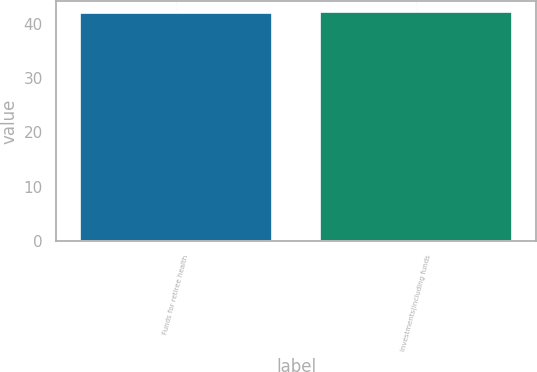Convert chart. <chart><loc_0><loc_0><loc_500><loc_500><bar_chart><fcel>Funds for retiree health<fcel>Investments(including funds<nl><fcel>42<fcel>42.1<nl></chart> 